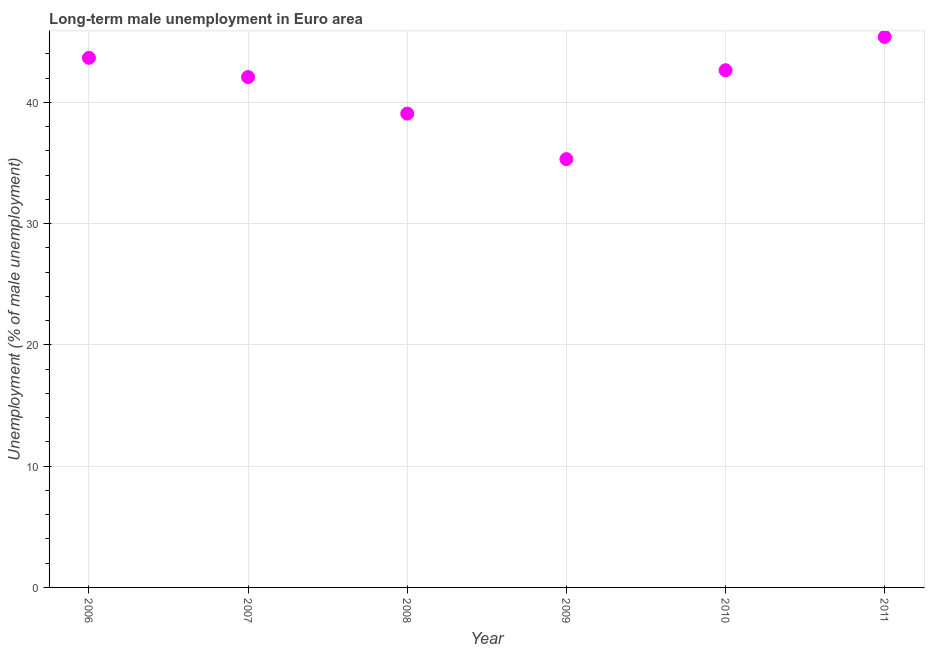What is the long-term male unemployment in 2010?
Provide a short and direct response. 42.65. Across all years, what is the maximum long-term male unemployment?
Offer a very short reply. 45.39. Across all years, what is the minimum long-term male unemployment?
Give a very brief answer. 35.32. In which year was the long-term male unemployment minimum?
Ensure brevity in your answer.  2009. What is the sum of the long-term male unemployment?
Offer a terse response. 248.17. What is the difference between the long-term male unemployment in 2010 and 2011?
Make the answer very short. -2.74. What is the average long-term male unemployment per year?
Your response must be concise. 41.36. What is the median long-term male unemployment?
Your answer should be very brief. 42.36. In how many years, is the long-term male unemployment greater than 32 %?
Provide a short and direct response. 6. Do a majority of the years between 2006 and 2007 (inclusive) have long-term male unemployment greater than 38 %?
Give a very brief answer. Yes. What is the ratio of the long-term male unemployment in 2007 to that in 2011?
Ensure brevity in your answer.  0.93. Is the long-term male unemployment in 2008 less than that in 2010?
Make the answer very short. Yes. Is the difference between the long-term male unemployment in 2008 and 2011 greater than the difference between any two years?
Your answer should be compact. No. What is the difference between the highest and the second highest long-term male unemployment?
Offer a terse response. 1.72. Is the sum of the long-term male unemployment in 2007 and 2008 greater than the maximum long-term male unemployment across all years?
Your answer should be very brief. Yes. What is the difference between the highest and the lowest long-term male unemployment?
Your answer should be very brief. 10.07. How many dotlines are there?
Offer a very short reply. 1. How many years are there in the graph?
Give a very brief answer. 6. Are the values on the major ticks of Y-axis written in scientific E-notation?
Offer a very short reply. No. Does the graph contain grids?
Give a very brief answer. Yes. What is the title of the graph?
Offer a terse response. Long-term male unemployment in Euro area. What is the label or title of the Y-axis?
Keep it short and to the point. Unemployment (% of male unemployment). What is the Unemployment (% of male unemployment) in 2006?
Give a very brief answer. 43.67. What is the Unemployment (% of male unemployment) in 2007?
Your answer should be compact. 42.08. What is the Unemployment (% of male unemployment) in 2008?
Your response must be concise. 39.07. What is the Unemployment (% of male unemployment) in 2009?
Give a very brief answer. 35.32. What is the Unemployment (% of male unemployment) in 2010?
Keep it short and to the point. 42.65. What is the Unemployment (% of male unemployment) in 2011?
Offer a terse response. 45.39. What is the difference between the Unemployment (% of male unemployment) in 2006 and 2007?
Your response must be concise. 1.59. What is the difference between the Unemployment (% of male unemployment) in 2006 and 2008?
Provide a short and direct response. 4.6. What is the difference between the Unemployment (% of male unemployment) in 2006 and 2009?
Ensure brevity in your answer.  8.35. What is the difference between the Unemployment (% of male unemployment) in 2006 and 2010?
Offer a terse response. 1.02. What is the difference between the Unemployment (% of male unemployment) in 2006 and 2011?
Provide a short and direct response. -1.72. What is the difference between the Unemployment (% of male unemployment) in 2007 and 2008?
Keep it short and to the point. 3.01. What is the difference between the Unemployment (% of male unemployment) in 2007 and 2009?
Give a very brief answer. 6.77. What is the difference between the Unemployment (% of male unemployment) in 2007 and 2010?
Give a very brief answer. -0.56. What is the difference between the Unemployment (% of male unemployment) in 2007 and 2011?
Give a very brief answer. -3.31. What is the difference between the Unemployment (% of male unemployment) in 2008 and 2009?
Your response must be concise. 3.75. What is the difference between the Unemployment (% of male unemployment) in 2008 and 2010?
Offer a terse response. -3.58. What is the difference between the Unemployment (% of male unemployment) in 2008 and 2011?
Your answer should be very brief. -6.32. What is the difference between the Unemployment (% of male unemployment) in 2009 and 2010?
Provide a succinct answer. -7.33. What is the difference between the Unemployment (% of male unemployment) in 2009 and 2011?
Make the answer very short. -10.07. What is the difference between the Unemployment (% of male unemployment) in 2010 and 2011?
Your response must be concise. -2.74. What is the ratio of the Unemployment (% of male unemployment) in 2006 to that in 2007?
Your answer should be very brief. 1.04. What is the ratio of the Unemployment (% of male unemployment) in 2006 to that in 2008?
Make the answer very short. 1.12. What is the ratio of the Unemployment (% of male unemployment) in 2006 to that in 2009?
Make the answer very short. 1.24. What is the ratio of the Unemployment (% of male unemployment) in 2006 to that in 2010?
Your answer should be compact. 1.02. What is the ratio of the Unemployment (% of male unemployment) in 2007 to that in 2008?
Offer a very short reply. 1.08. What is the ratio of the Unemployment (% of male unemployment) in 2007 to that in 2009?
Provide a short and direct response. 1.19. What is the ratio of the Unemployment (% of male unemployment) in 2007 to that in 2011?
Provide a succinct answer. 0.93. What is the ratio of the Unemployment (% of male unemployment) in 2008 to that in 2009?
Ensure brevity in your answer.  1.11. What is the ratio of the Unemployment (% of male unemployment) in 2008 to that in 2010?
Provide a succinct answer. 0.92. What is the ratio of the Unemployment (% of male unemployment) in 2008 to that in 2011?
Make the answer very short. 0.86. What is the ratio of the Unemployment (% of male unemployment) in 2009 to that in 2010?
Your answer should be very brief. 0.83. What is the ratio of the Unemployment (% of male unemployment) in 2009 to that in 2011?
Make the answer very short. 0.78. 